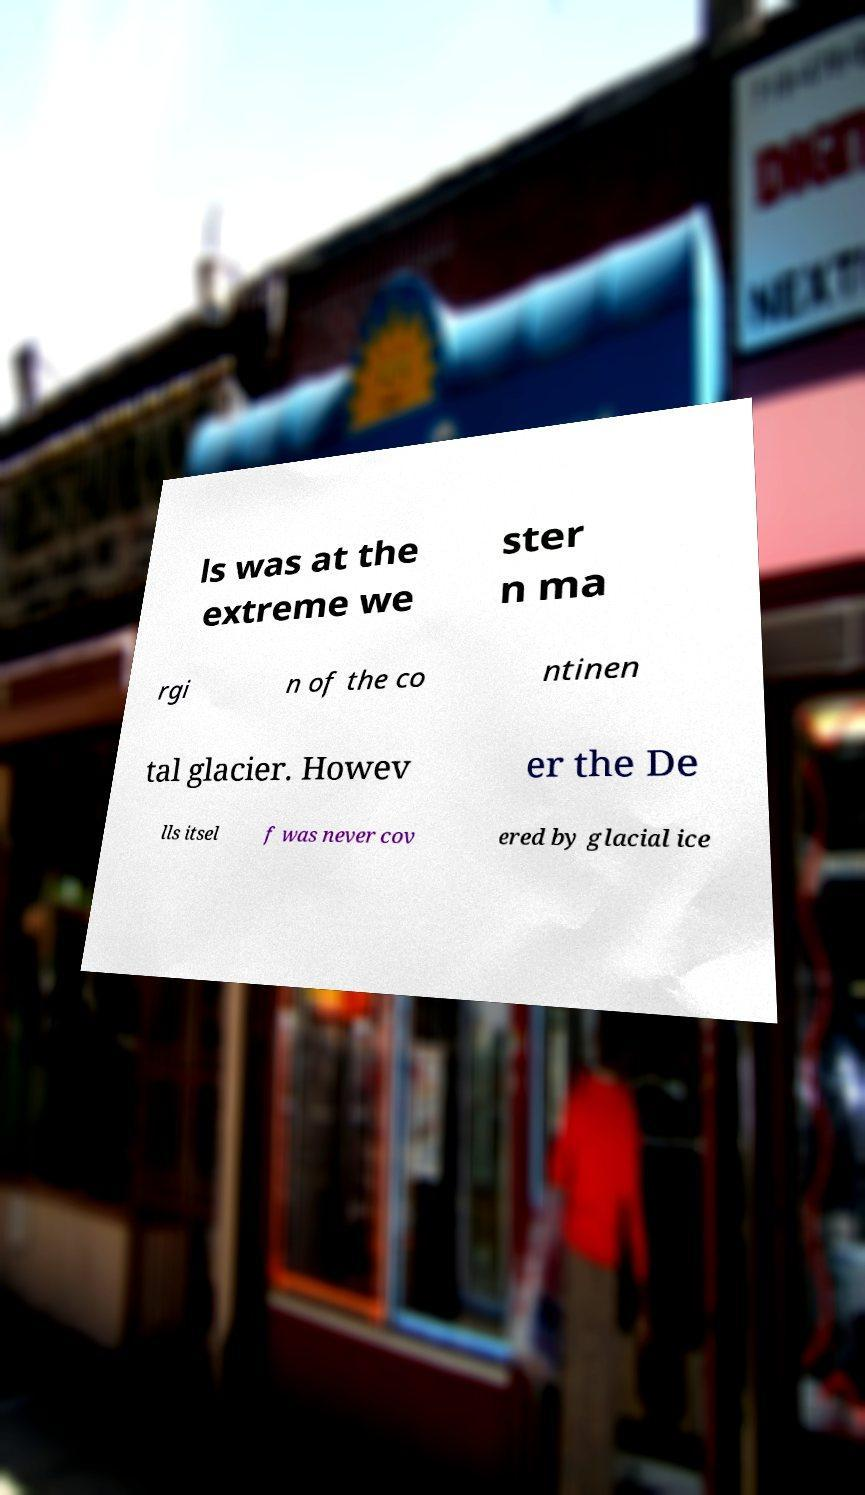Can you accurately transcribe the text from the provided image for me? ls was at the extreme we ster n ma rgi n of the co ntinen tal glacier. Howev er the De lls itsel f was never cov ered by glacial ice 